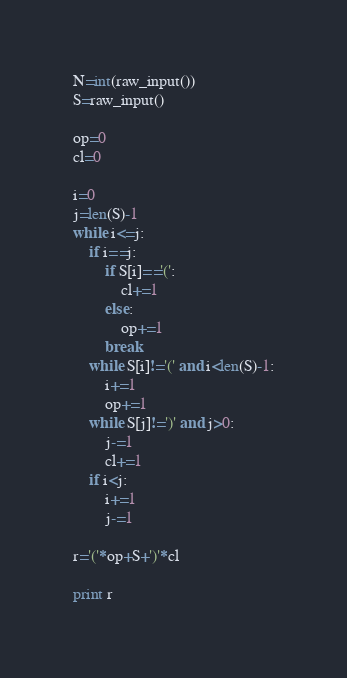<code> <loc_0><loc_0><loc_500><loc_500><_Python_>N=int(raw_input())
S=raw_input()

op=0
cl=0

i=0
j=len(S)-1
while i<=j:
    if i==j:
        if S[i]=='(':
            cl+=1
        else:
            op+=1
        break
    while S[i]!='(' and i<len(S)-1:
        i+=1
        op+=1
    while S[j]!=')' and j>0:
        j-=1
        cl+=1
    if i<j:
        i+=1
        j-=1

r='('*op+S+')'*cl

print r</code> 